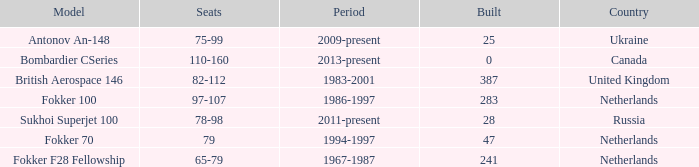Between which years were there 241 fokker 70 model cabins built? 1994-1997. 